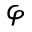<formula> <loc_0><loc_0><loc_500><loc_500>\varphi</formula> 